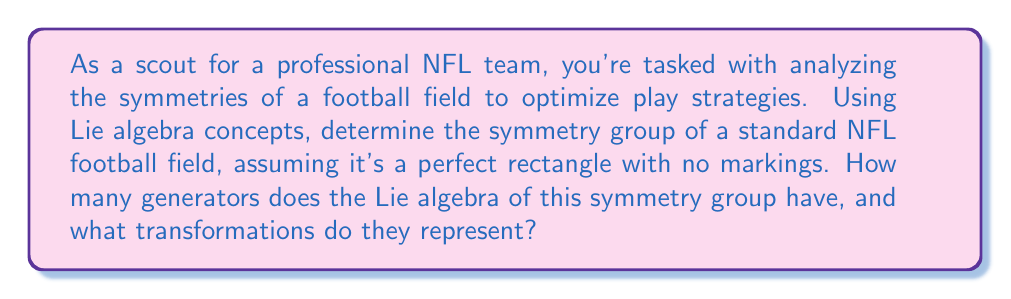Help me with this question. To solve this problem, we'll follow these steps:

1) First, let's consider the symmetries of a rectangular football field:
   - Translations along the length and width
   - Rotations by 180 degrees around the center
   - Reflections across the midfield line and the line perpendicular to it through the center

2) These symmetries form the symmetry group of the rectangle, which is isomorphic to the orthogonal group $O(2)$ combined with translations in two dimensions. This group is known as the Euclidean group $E(2)$.

3) The Lie algebra of $E(2)$, denoted as $\mathfrak{e}(2)$, is the infinitesimal version of these symmetries.

4) The generators of $\mathfrak{e}(2)$ correspond to:
   - Two translations: one along the length ($T_x$) and one along the width ($T_y$)
   - One rotation around the center ($R$)

5) Mathematically, these generators can be represented as:

   $T_x = \begin{pmatrix} 0 & 0 & 1 \\ 0 & 0 & 0 \\ 0 & 0 & 0 \end{pmatrix}$

   $T_y = \begin{pmatrix} 0 & 0 & 0 \\ 0 & 0 & 1 \\ 0 & 0 & 0 \end{pmatrix}$

   $R = \begin{pmatrix} 0 & -1 & 0 \\ 1 & 0 & 0 \\ 0 & 0 & 0 \end{pmatrix}$

6) These three generators form a basis for the Lie algebra $\mathfrak{e}(2)$.

7) The reflections are discrete symmetries and don't contribute to the Lie algebra generators.

Therefore, the Lie algebra of the symmetry group of the football field has 3 generators, representing two translations and one rotation.
Answer: The Lie algebra of the symmetry group of a standard NFL football field (modeled as a perfect rectangle) has 3 generators, representing two translations (along the length and width) and one rotation (around the center). 